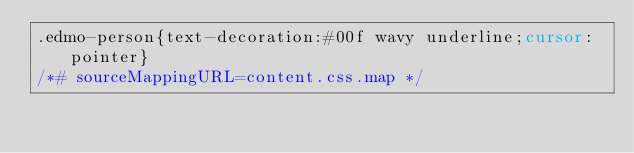Convert code to text. <code><loc_0><loc_0><loc_500><loc_500><_CSS_>.edmo-person{text-decoration:#00f wavy underline;cursor:pointer}
/*# sourceMappingURL=content.css.map */
</code> 